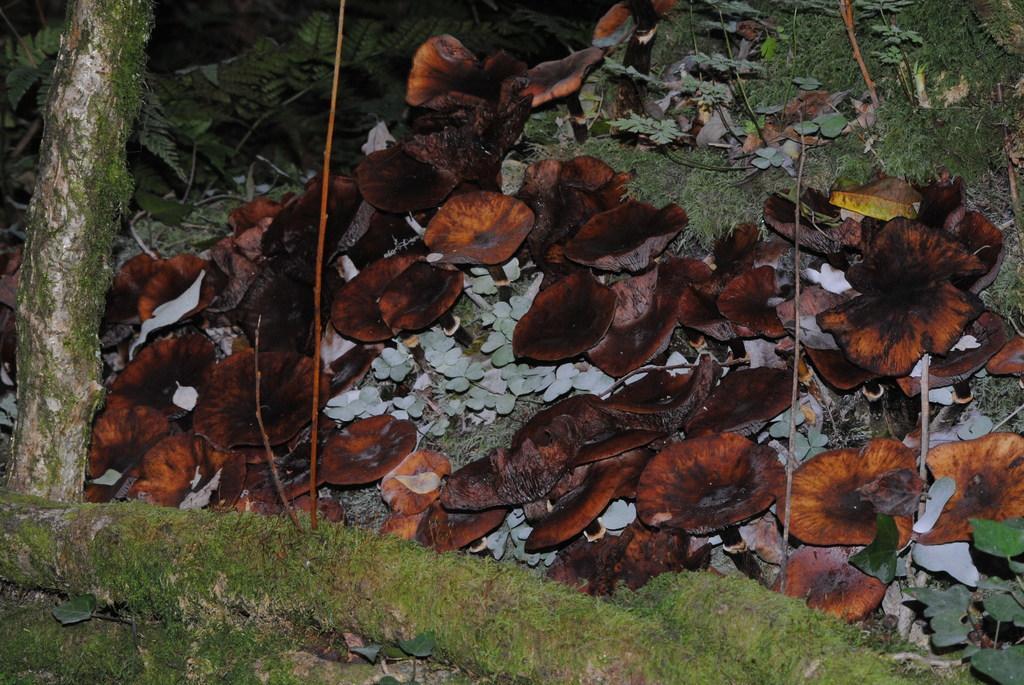How would you summarize this image in a sentence or two? In this image I can see brown colour leaves and green grass. I can also see tree trunks over here. 